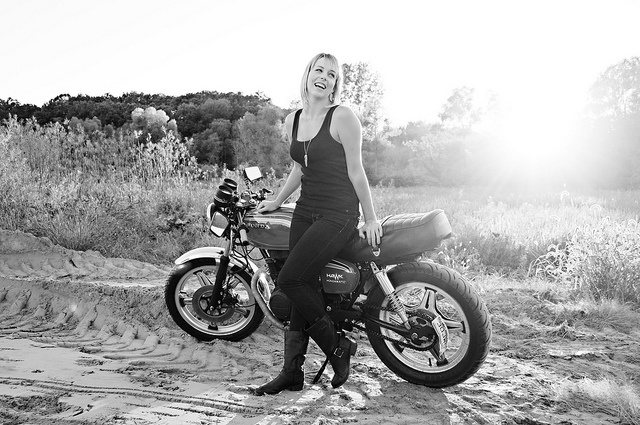Describe the objects in this image and their specific colors. I can see motorcycle in white, black, gray, darkgray, and lightgray tones and people in white, black, darkgray, gray, and lightgray tones in this image. 